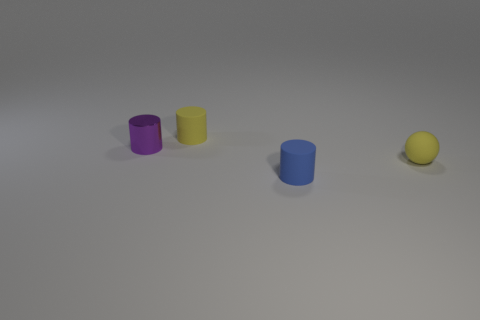Is there any other thing that has the same material as the yellow sphere?
Offer a terse response. Yes. How many tiny cylinders are the same color as the tiny ball?
Ensure brevity in your answer.  1. There is a tiny cylinder that is the same color as the tiny rubber ball; what is it made of?
Provide a succinct answer. Rubber. Is there any other thing that is the same shape as the purple object?
Give a very brief answer. Yes. Is the material of the tiny purple cylinder the same as the yellow thing that is on the right side of the blue matte object?
Offer a very short reply. No. How many blue things are small balls or cylinders?
Give a very brief answer. 1. Are there any large red rubber things?
Keep it short and to the point. No. There is a tiny yellow object in front of the small matte cylinder that is behind the metallic cylinder; are there any yellow matte cylinders that are behind it?
Keep it short and to the point. Yes. There is a blue matte thing; is it the same shape as the tiny yellow rubber thing in front of the small purple shiny thing?
Keep it short and to the point. No. There is a rubber thing that is in front of the yellow matte thing on the right side of the object that is in front of the matte sphere; what color is it?
Provide a short and direct response. Blue. 